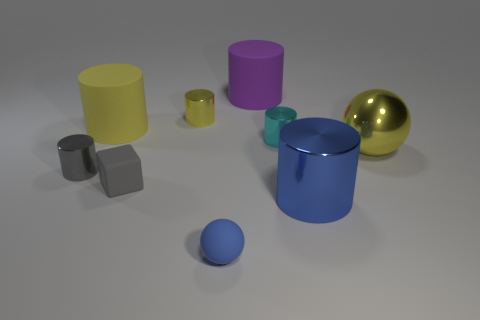Subtract all gray metal cylinders. How many cylinders are left? 5 Subtract all gray cylinders. How many cylinders are left? 5 Subtract all cyan cylinders. Subtract all cyan blocks. How many cylinders are left? 5 Add 1 large yellow matte blocks. How many objects exist? 10 Subtract all spheres. How many objects are left? 7 Add 8 blocks. How many blocks exist? 9 Subtract 1 gray cubes. How many objects are left? 8 Subtract all tiny purple shiny cubes. Subtract all yellow metallic spheres. How many objects are left? 8 Add 1 big yellow spheres. How many big yellow spheres are left? 2 